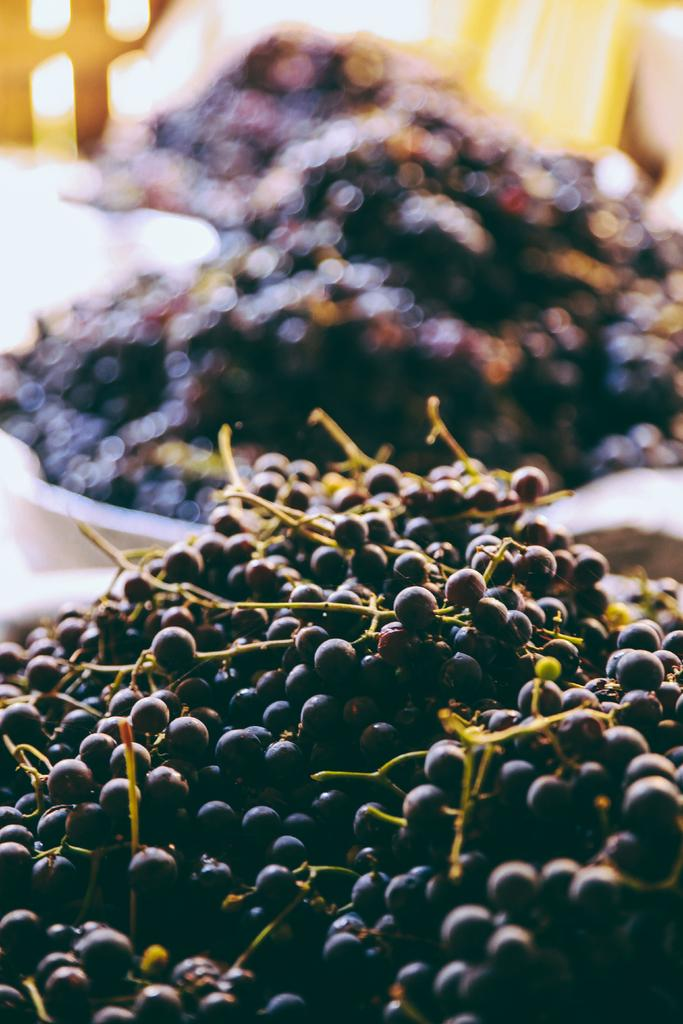What type of fruit is in the foreground of the image? There are grapes in the foreground of the image. What objects are in the background of the image? There are plates in the background of the image. What is on the plates in the image? The plates contain grapes. How would you describe the appearance of the background in the image? The background of the image is blurred. What type of paper can be seen wrapped around the snake in the image? There is no snake or paper present in the image; it features grapes in the foreground and plates in the background. 